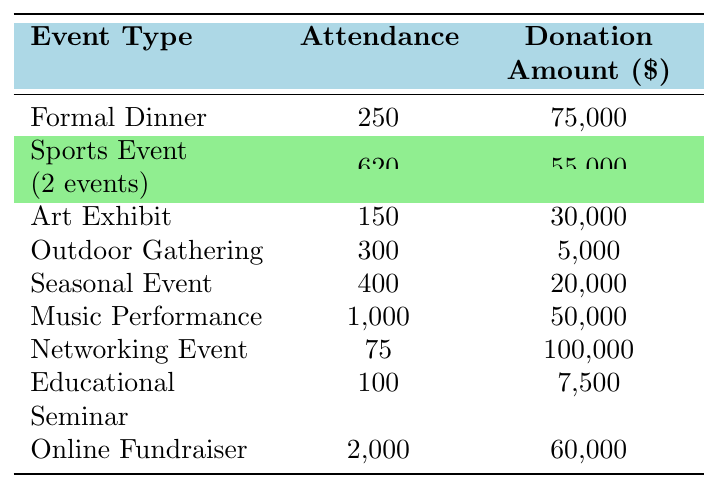What is the total attendance for the "Networking Event"? The table shows that the "Corporate Sponsorship Breakfast," which is categorized as a Networking Event, has an attendance of 75. Therefore, the total attendance for this event is 75.
Answer: 75 What is the combined donation amount from all events categorized as "Sports Event"? There are two events listed under "Sports Event": the "Run for a Cause 5K" with a donation amount of 15,000 and the "Charity Golf Tournament" with a donation amount of 40,000. Adding these amounts gives 15,000 + 40,000 = 55,000.
Answer: 55,000 Is the "Community Art Auction" the only event in its category? The table indicates that "Community Art Auction" is classified under the "Art Exhibit" category, and there are no other events listed as "Art Exhibit." Therefore, it is the only event in that category.
Answer: Yes What is the average donation amount for the events listed as "Outdoor Gathering"? The table shows one event in this category, the "Volunteer Appreciation Picnic," with a donation amount of 5,000. Since there's only one event, the average donation amount is simply 5,000.
Answer: 5,000 Which event had the highest attendance and what was the amount donated for that event? The "Virtual Telethon" had the highest attendance at 2,000, and the donation amount associated with this event is 60,000.
Answer: 2,000 attendees; 60,000 donated How much more did the "Corporate Sponsorship Breakfast" raise than the "Volunteer Appreciation Picnic"? "Corporate Sponsorship Breakfast" raised 100,000, while the "Volunteer Appreciation Picnic" raised 5,000. The difference is calculated as 100,000 - 5,000 = 95,000.
Answer: 95,000 What percentage of total attendance does the "Annual Charity Gala" represent? To find the percentage of total attendance, first sum up the attendance for all events: 250 + 500 + 150 + 300 + 400 + 1000 + 75 + 100 + 2000 = 3875. The "Annual Charity Gala" has 250 attendees. The percentage calculation is (250 / 3875) * 100 = 6.45%.
Answer: 6.45% Which event type had the least amount of donations? The "Outdoor Gathering" type, which includes the "Volunteer Appreciation Picnic," had the least amount of donations totaling 5,000.
Answer: Outdoor Gathering How many total events were categorized under "Educational Seminar"? There is one event listed as "Educational Seminar," the "Youth Leadership Workshop." Thus, the total number of events in this category is 1.
Answer: 1 What is the median attendance among the different event types? First, list the attendance figures in ascending order: 75, 100, 150, 250, 300, 400, 500, 1,000, 2,000. The median (middle value) is calculated as the average of the 4th and 5th attendance figures (250 and 300), which is (250 + 300) / 2 = 275.
Answer: 275 